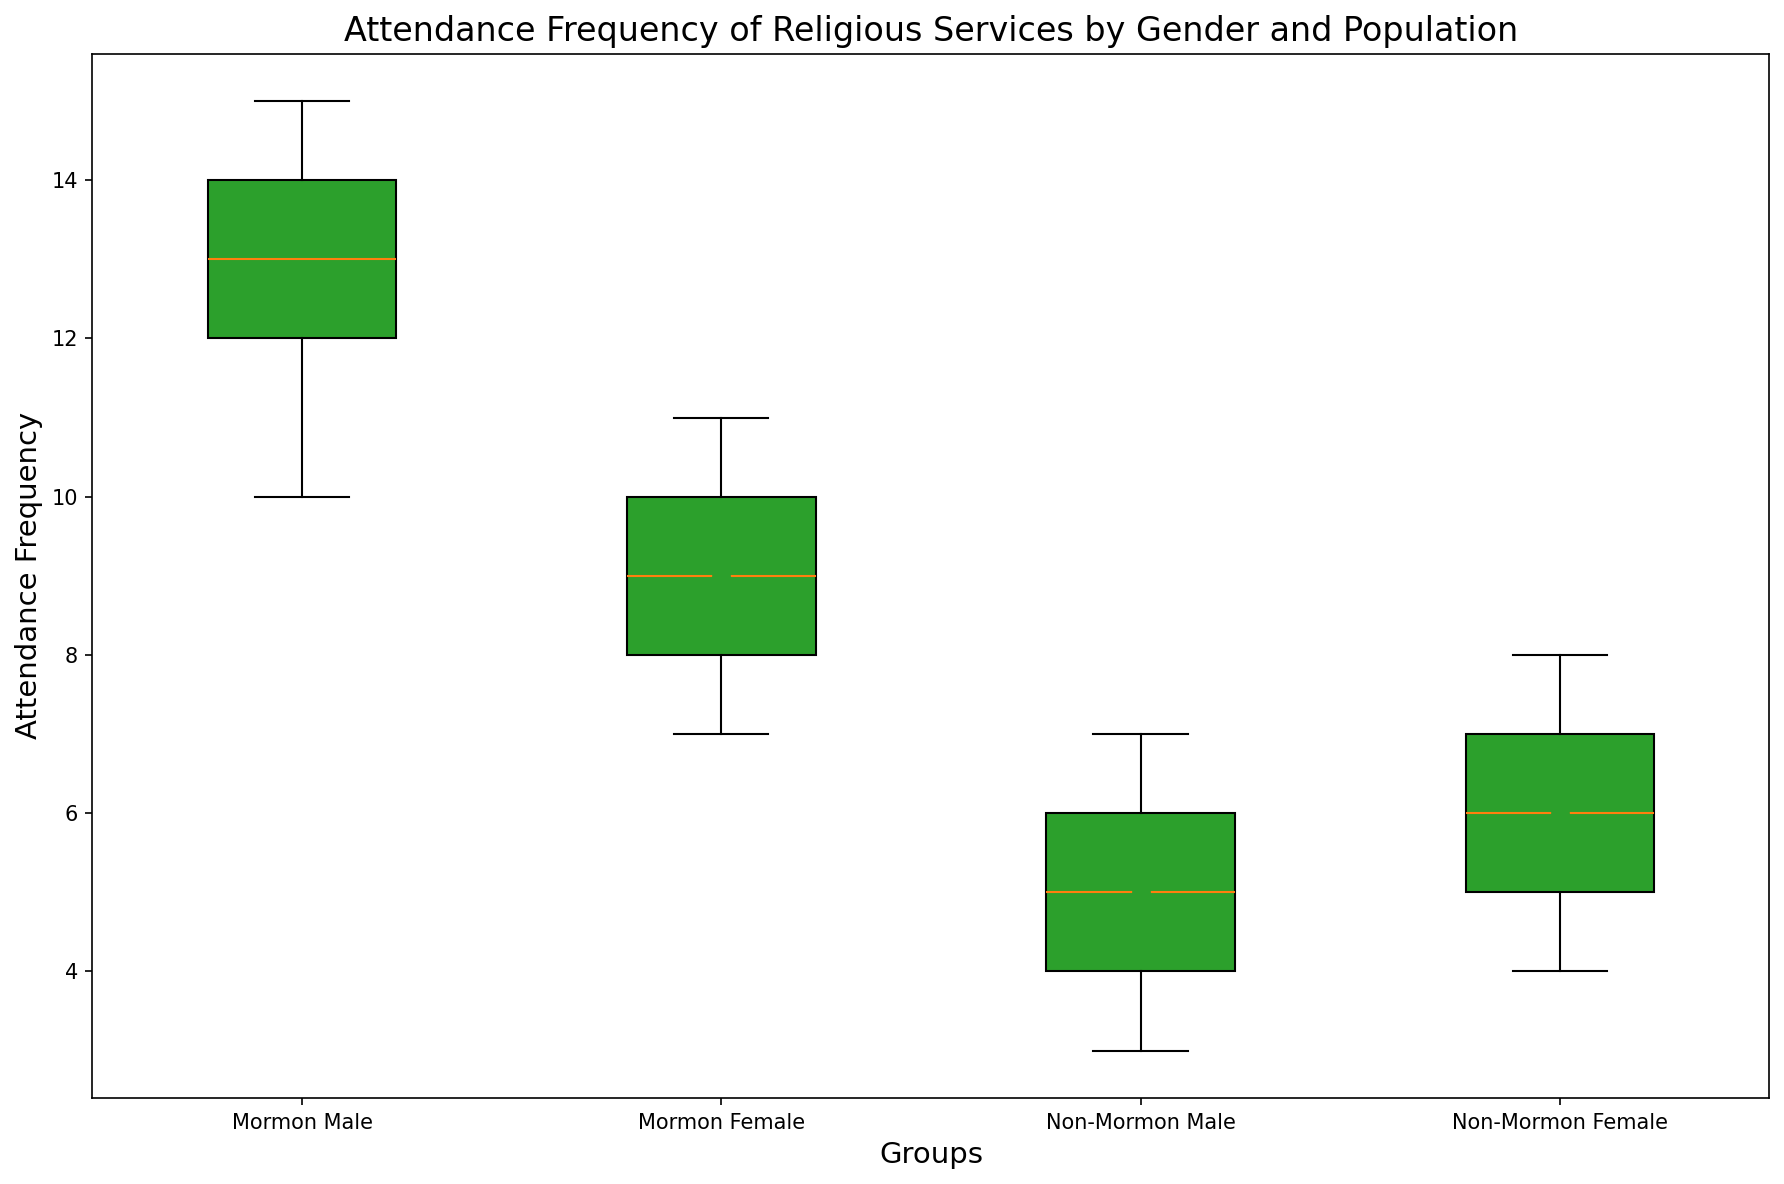How do the median attendance frequencies compare between Mormon males and Non-Mormon males? To determine this, locate the median line within each box plot for both groups. The median attendance frequency for Mormon males appears to be around 12 or 13, whereas for Non-Mormon males, it is around 5.
Answer: The median for Mormon males is higher than for Non-Mormon males Which group has the highest mean attendance frequency? Examine the positions of the blue mean marker points. The blue marker point for Mormon males is noticeably higher than the markers for other groups, indicating a higher mean attendance frequency.
Answer: Mormon males Are there any outliers in the female groups? Outliers are usually indicated by individual points outside the whiskers of the box plot. In the Mormon and Non-Mormon female groups, no such points are visible outside the whiskers.
Answer: No What is the range of attendance frequency for Non-Mormon females? The range can be determined by subtracting the minimum value (bottom whisker) from the maximum value (top whisker) in the box plot. For Non-Mormon females, the top whisker is at 8 and the bottom whisker is at 4, making the range 8 - 4.
Answer: 4 Compare the interquartile ranges (IQR) for Mormon males and Non-Mormon females. The IQR is the difference between the first quartile (bottom of the box) and the third quartile (top of the box). For Mormon males, IQR is from about 10 to 14 (14 - 10 = 4). For Non-Mormon females, IQR is from about 5 to 7 (7 - 5 = 2).
Answer: IQR for Mormon males is larger What is the difference between the highest attendance frequency of Mormon males and Non-Mormon males? The highest attendance frequency for Mormon males can be observed at the top whisker or outlier, which is about 15. For Non-Mormon males, the top whisker reaches around 7. So the difference is 15 - 7.
Answer: 8 Does any group have a symmetric distribution of attendance frequency? A symmetric distribution can be observed if the median line is centered and the lengths of the whiskers and box halves are approximately equal. None of the groups exhibit precise symmetry, though Non-Mormon males might be closest.
Answer: No group exhibits perfect symmetry Which female group has a higher mean attendance frequency? Compare the positions of the blue marker points for both female groups. The blue marker for Mormon females is slightly higher than for Non-Mormon females.
Answer: Mormon females How much higher is the highest attendance frequency of Mormon females compared to Non-Mormon females? The top whisker for Mormon females is at 11, and for Non-Mormon females, the top whisker is at 8. Therefore, the difference is 11 - 8.
Answer: 3 What can you infer about the overall distribution shape for Non-Mormon males? The box plot shows a long lower whisker and a majority of data points in the lower range, indicative of a left-skewed (negative skew) distribution.
Answer: Left-skewed 